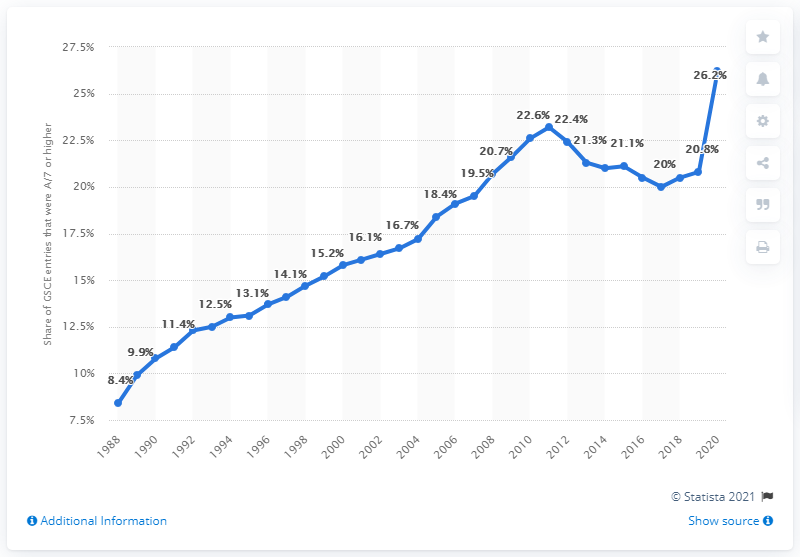List a handful of essential elements in this visual. In 1988, the pass rate for GCSE students was 8.4%. 